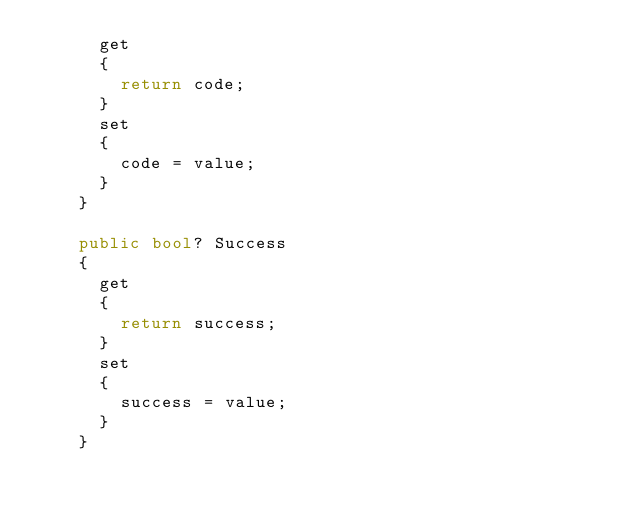Convert code to text. <code><loc_0><loc_0><loc_500><loc_500><_C#_>			get
			{
				return code;
			}
			set	
			{
				code = value;
			}
		}

		public bool? Success
		{
			get
			{
				return success;
			}
			set	
			{
				success = value;
			}
		}
</code> 